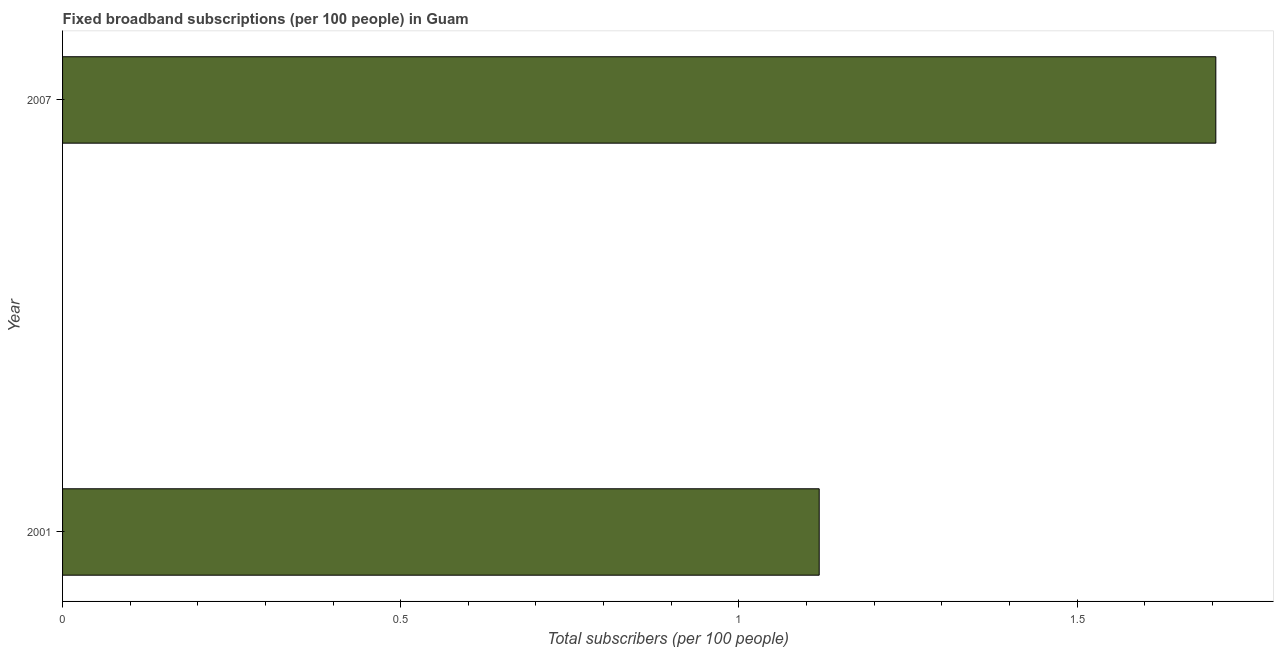Does the graph contain grids?
Offer a terse response. No. What is the title of the graph?
Give a very brief answer. Fixed broadband subscriptions (per 100 people) in Guam. What is the label or title of the X-axis?
Provide a succinct answer. Total subscribers (per 100 people). What is the label or title of the Y-axis?
Your answer should be very brief. Year. What is the total number of fixed broadband subscriptions in 2007?
Ensure brevity in your answer.  1.71. Across all years, what is the maximum total number of fixed broadband subscriptions?
Keep it short and to the point. 1.71. Across all years, what is the minimum total number of fixed broadband subscriptions?
Keep it short and to the point. 1.12. In which year was the total number of fixed broadband subscriptions minimum?
Provide a succinct answer. 2001. What is the sum of the total number of fixed broadband subscriptions?
Provide a succinct answer. 2.82. What is the difference between the total number of fixed broadband subscriptions in 2001 and 2007?
Your response must be concise. -0.59. What is the average total number of fixed broadband subscriptions per year?
Provide a short and direct response. 1.41. What is the median total number of fixed broadband subscriptions?
Offer a very short reply. 1.41. What is the ratio of the total number of fixed broadband subscriptions in 2001 to that in 2007?
Keep it short and to the point. 0.66. Is the total number of fixed broadband subscriptions in 2001 less than that in 2007?
Provide a short and direct response. Yes. In how many years, is the total number of fixed broadband subscriptions greater than the average total number of fixed broadband subscriptions taken over all years?
Provide a short and direct response. 1. Are all the bars in the graph horizontal?
Provide a succinct answer. Yes. How many years are there in the graph?
Give a very brief answer. 2. Are the values on the major ticks of X-axis written in scientific E-notation?
Make the answer very short. No. What is the Total subscribers (per 100 people) in 2001?
Give a very brief answer. 1.12. What is the Total subscribers (per 100 people) of 2007?
Your response must be concise. 1.71. What is the difference between the Total subscribers (per 100 people) in 2001 and 2007?
Provide a short and direct response. -0.59. What is the ratio of the Total subscribers (per 100 people) in 2001 to that in 2007?
Offer a terse response. 0.66. 